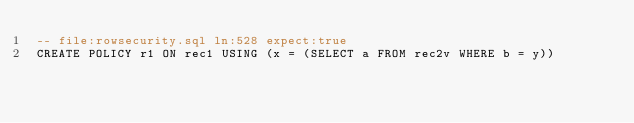Convert code to text. <code><loc_0><loc_0><loc_500><loc_500><_SQL_>-- file:rowsecurity.sql ln:528 expect:true
CREATE POLICY r1 ON rec1 USING (x = (SELECT a FROM rec2v WHERE b = y))
</code> 